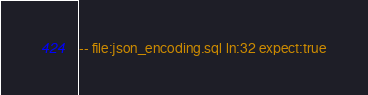<code> <loc_0><loc_0><loc_500><loc_500><_SQL_>-- file:json_encoding.sql ln:32 expect:true</code> 